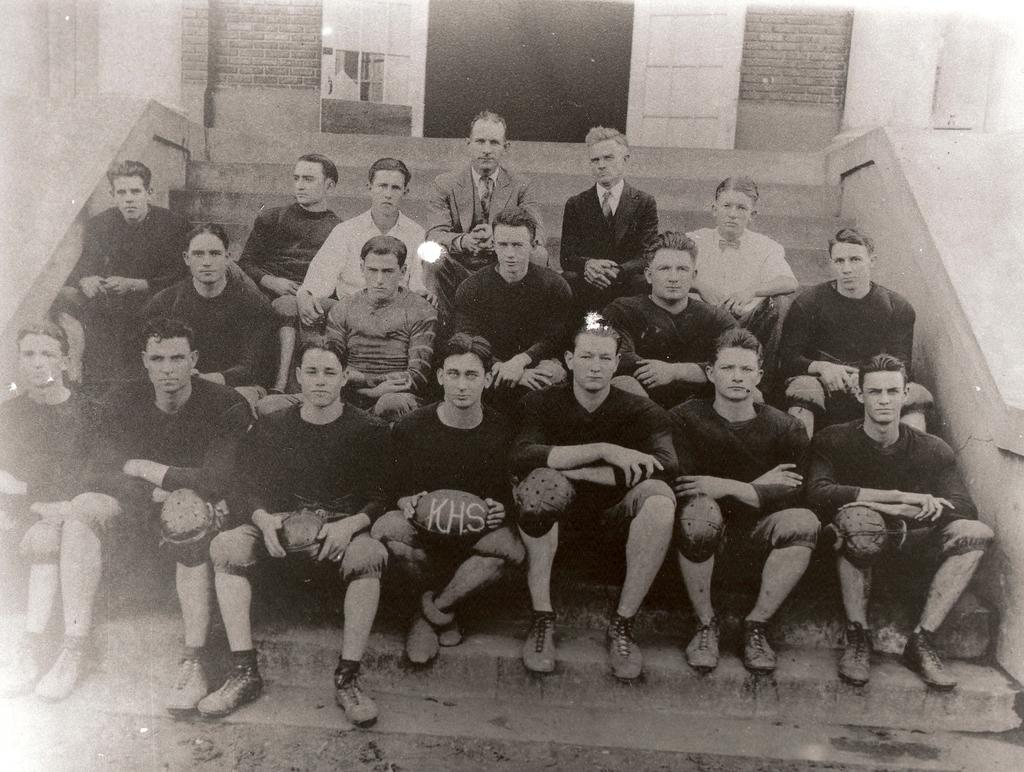What is the main subject of the image? The main subject of the image is a group of people. Where are the people in the image located? The people are sitting on a staircase. What are two of the people holding in the image? Two persons are holding balls in the image. What can be seen in the background of the image? There is a building in the background of the image. How many girls are present in the image? The provided facts do not mention the gender of the people in the image, so it is impossible to determine the number of girls present. 